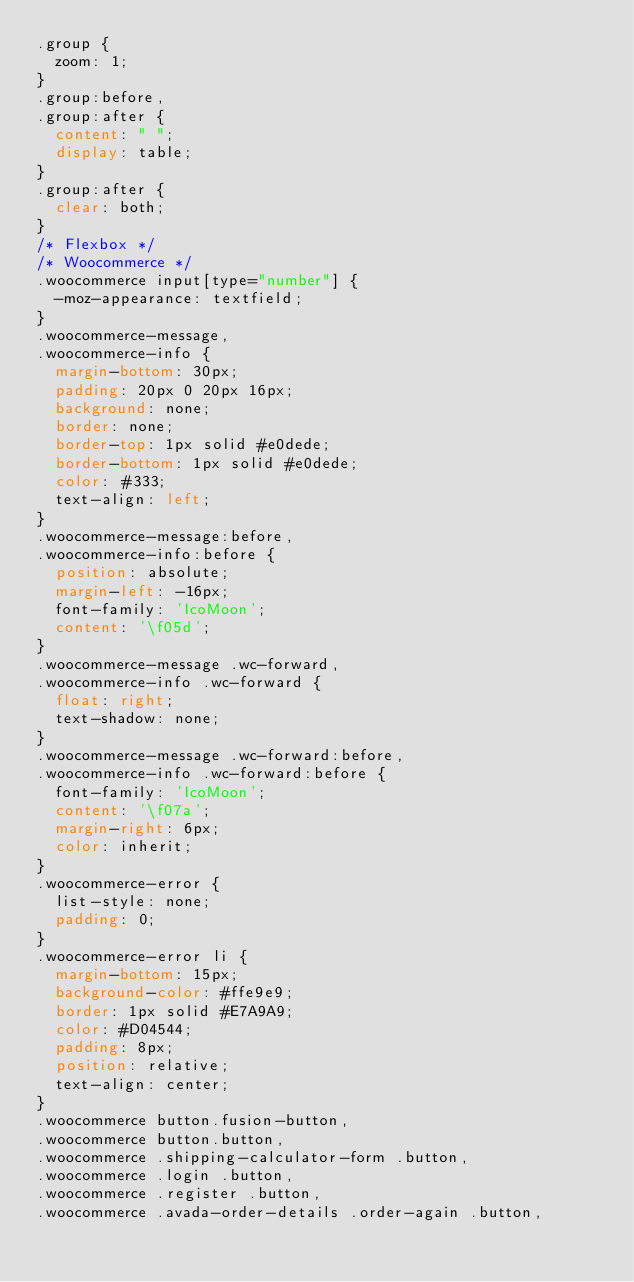<code> <loc_0><loc_0><loc_500><loc_500><_CSS_>.group {
  zoom: 1;
}
.group:before,
.group:after {
  content: " ";
  display: table;
}
.group:after {
  clear: both;
}
/* Flexbox */
/* Woocommerce */
.woocommerce input[type="number"] {
  -moz-appearance: textfield;
}
.woocommerce-message,
.woocommerce-info {
  margin-bottom: 30px;
  padding: 20px 0 20px 16px;
  background: none;
  border: none;
  border-top: 1px solid #e0dede;
  border-bottom: 1px solid #e0dede;
  color: #333;
  text-align: left;
}
.woocommerce-message:before,
.woocommerce-info:before {
  position: absolute;
  margin-left: -16px;
  font-family: 'IcoMoon';
  content: '\f05d';
}
.woocommerce-message .wc-forward,
.woocommerce-info .wc-forward {
  float: right;
  text-shadow: none;
}
.woocommerce-message .wc-forward:before,
.woocommerce-info .wc-forward:before {
  font-family: 'IcoMoon';
  content: '\f07a';
  margin-right: 6px;
  color: inherit;
}
.woocommerce-error {
  list-style: none;
  padding: 0;
}
.woocommerce-error li {
  margin-bottom: 15px;
  background-color: #ffe9e9;
  border: 1px solid #E7A9A9;
  color: #D04544;
  padding: 8px;
  position: relative;
  text-align: center;
}
.woocommerce button.fusion-button,
.woocommerce button.button,
.woocommerce .shipping-calculator-form .button,
.woocommerce .login .button,
.woocommerce .register .button,
.woocommerce .avada-order-details .order-again .button,</code> 